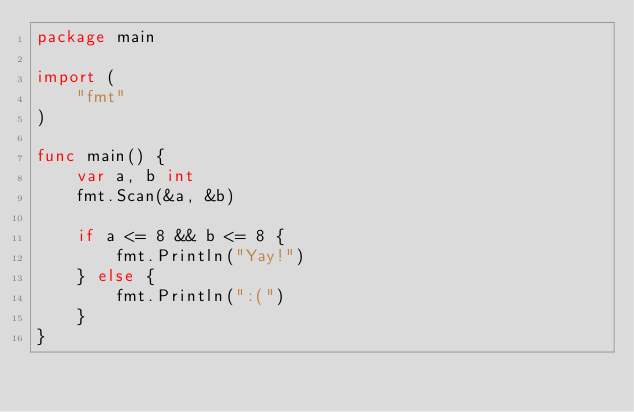<code> <loc_0><loc_0><loc_500><loc_500><_Go_>package main

import (
	"fmt"
)

func main() {
	var a, b int
	fmt.Scan(&a, &b)

	if a <= 8 && b <= 8 {
		fmt.Println("Yay!")
	} else {
		fmt.Println(":(")
	}
}
</code> 